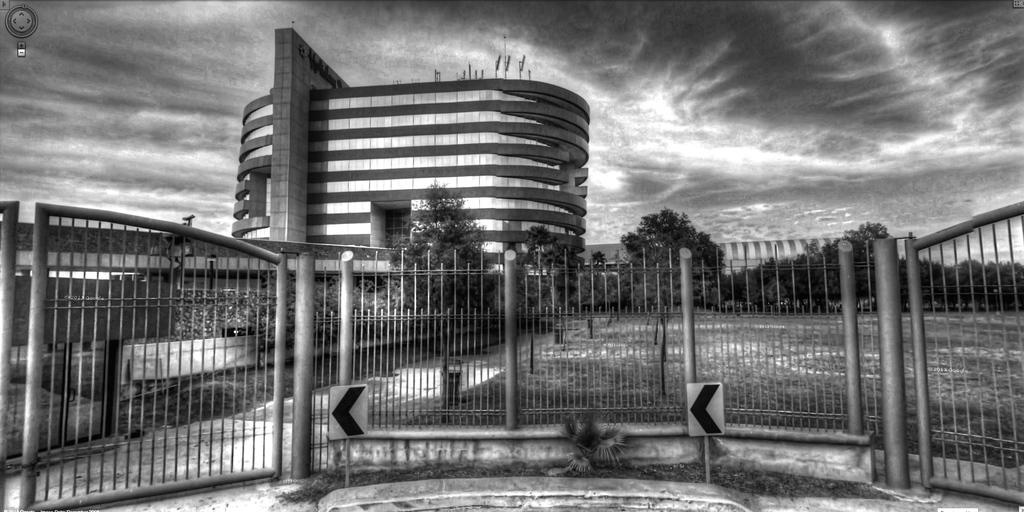What type of structure is present in the image? There is a building in the image. What is located at the bottom of the image? There is a fence at the bottom of the image. Is there any entrance or exit visible in the image? Yes, there is a gate in the image. What material can be seen in the image? Boards are visible in the image. What can be seen in the distance in the image? There are trees and the sky visible in the background of the image. What is the purpose of the downtown area in the image? There is no downtown area present in the image, so it is not possible to determine its purpose. 